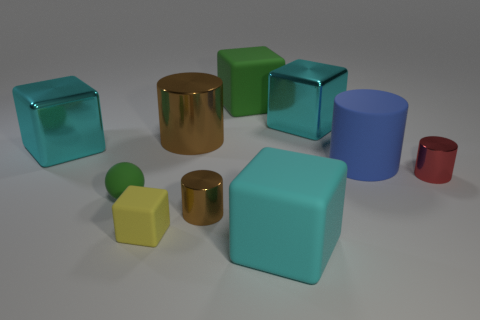What number of things are big metal objects or rubber objects on the right side of the small yellow matte cube?
Offer a terse response. 6. What number of blue rubber objects are right of the big object that is to the right of the large metal cube on the right side of the tiny yellow matte object?
Ensure brevity in your answer.  0. The tiny sphere that is made of the same material as the small yellow block is what color?
Provide a succinct answer. Green. There is a brown shiny cylinder in front of the matte ball; is it the same size as the green cube?
Your response must be concise. No. How many things are small rubber cylinders or tiny yellow cubes?
Make the answer very short. 1. There is a large cyan block in front of the brown shiny cylinder that is in front of the green rubber object in front of the large green rubber thing; what is it made of?
Your answer should be very brief. Rubber. There is a cyan cube left of the green matte sphere; what material is it?
Your answer should be very brief. Metal. Is there a cylinder of the same size as the yellow rubber cube?
Give a very brief answer. Yes. Do the large rubber object that is in front of the yellow matte block and the rubber sphere have the same color?
Keep it short and to the point. No. How many cyan things are large matte cubes or rubber blocks?
Keep it short and to the point. 1. 